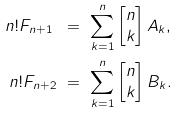Convert formula to latex. <formula><loc_0><loc_0><loc_500><loc_500>n ! F _ { n + 1 } \ & = \ \sum _ { k = 1 } ^ { n } \begin{bmatrix} n \\ k \end{bmatrix} A _ { k } , \\ n ! F _ { n + 2 } \ & = \ \sum _ { k = 1 } ^ { n } \begin{bmatrix} n \\ k \end{bmatrix} B _ { k } . \\</formula> 